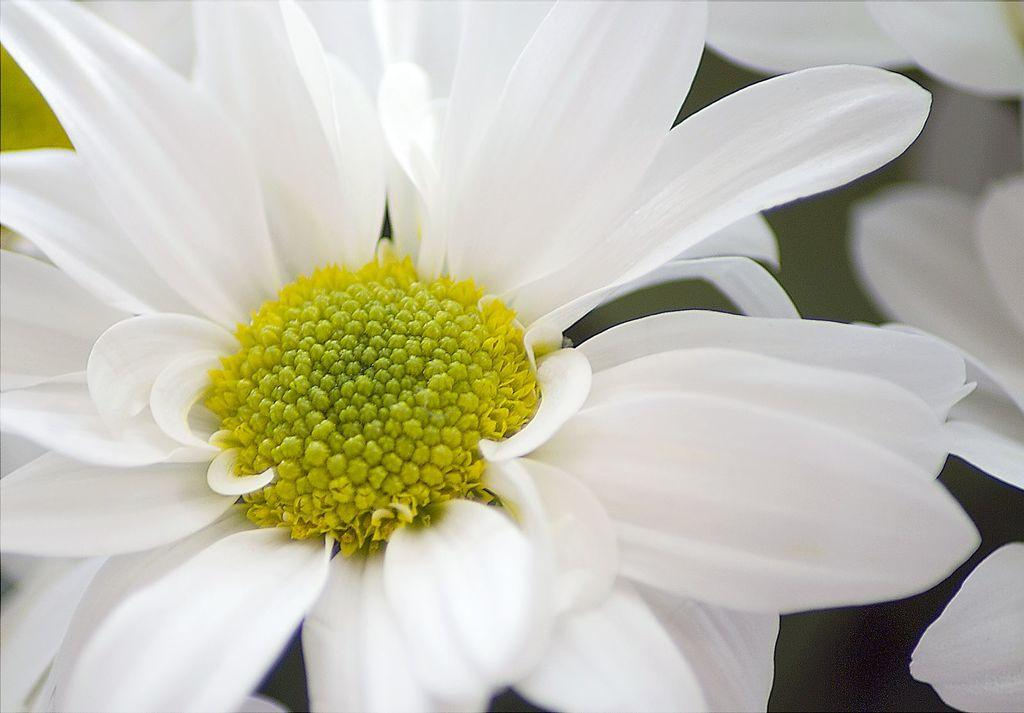What type of objects are present in the image? There are flowers in the image. What colors can be seen on the flowers? The flowers have white, yellow, and green colors. Can you describe the background of the image? The background of the image is blurry. Where is the mitten located in the image? There is no mitten present in the image. What type of bird can be seen interacting with the flowers in the image? There is no bird, including a hen, present in the image. 